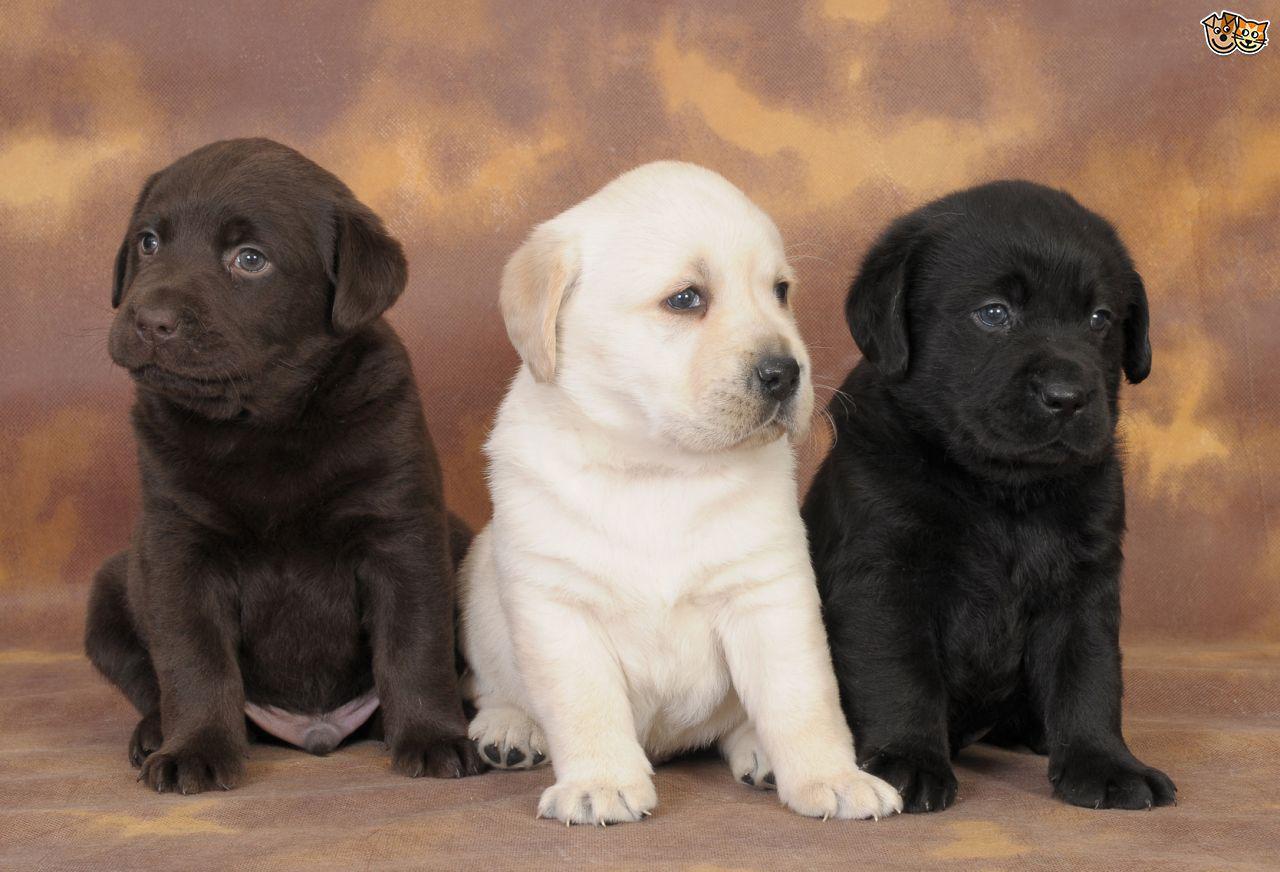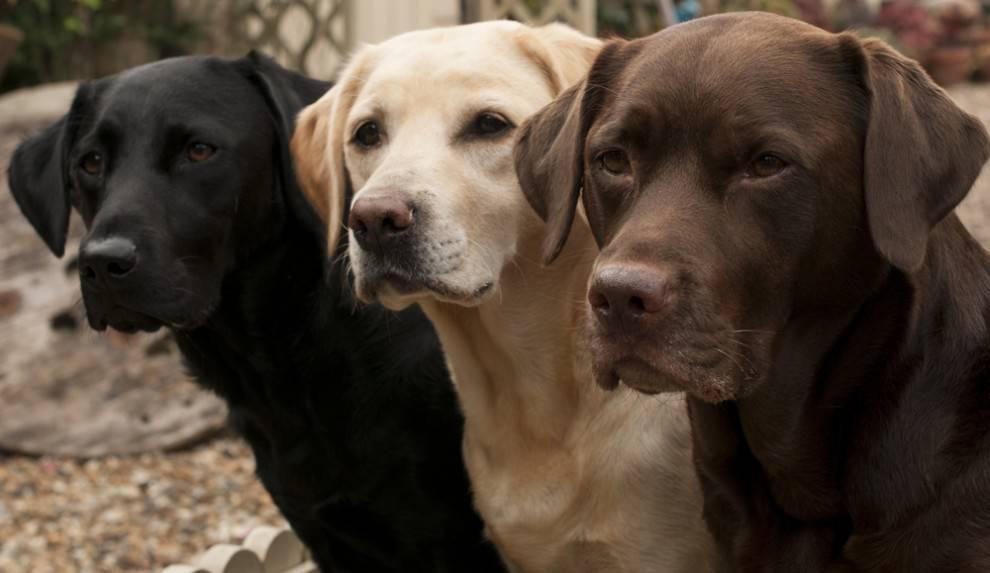The first image is the image on the left, the second image is the image on the right. Given the left and right images, does the statement "6 dogs exactly can be seen." hold true? Answer yes or no. Yes. The first image is the image on the left, the second image is the image on the right. Assess this claim about the two images: "An image shows three upright, non-reclining dogs posed with the black dog on the far left and the brown dog on the far right.". Correct or not? Answer yes or no. Yes. 